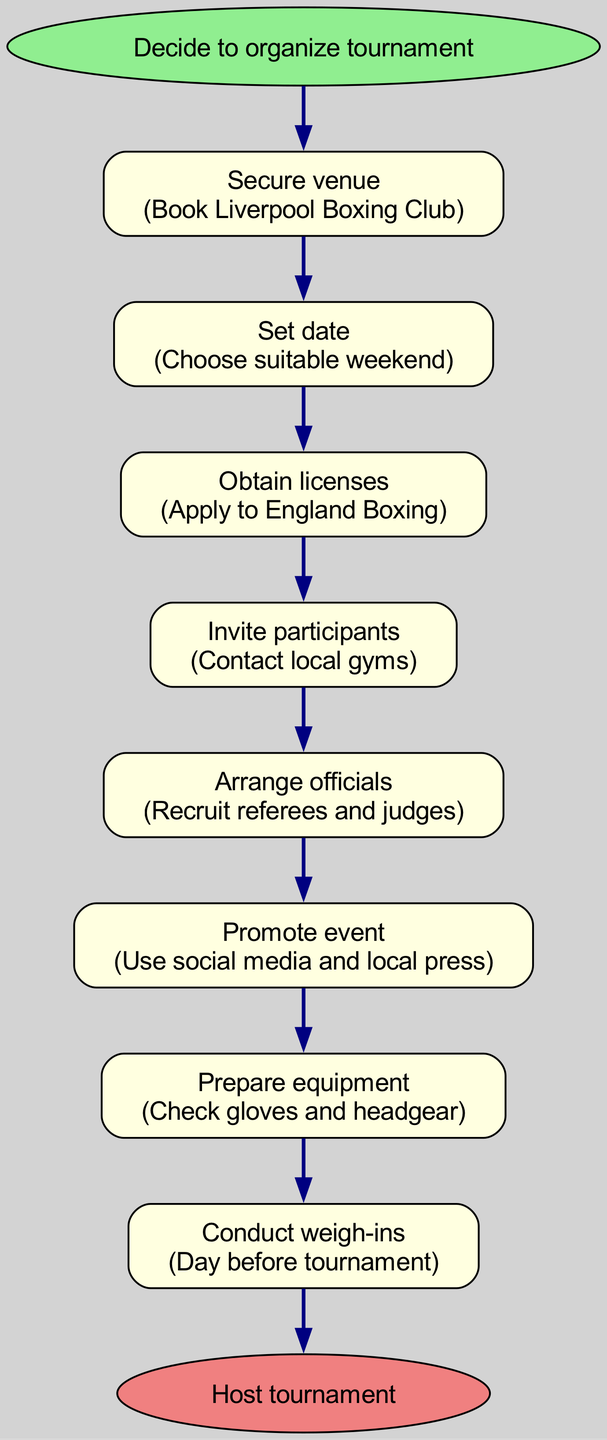What is the first step in organizing the tournament? The first step is listed directly from the start node of the diagram, which states, "Decide to organize tournament."
Answer: Decide to organize tournament How many steps are there in the process? To find the total number of steps, count each individual step node listed, which sums up to eight steps, including securing a venue, setting the date, obtaining licenses, inviting participants, arranging officials, promoting the event, preparing equipment, and conducting weigh-ins.
Answer: Eight steps What is the final outcome of this flow chart? The final outcome is indicated at the end node of the diagram, which states, "Host tournament."
Answer: Host tournament What follows after "Obtain licenses"? The diagram shows that after "Obtain licenses," the next step is "Invite participants." This is indicated by the connecting edge between the two nodes.
Answer: Invite participants What action is taken to promote the event? The relevant step in the diagram specifies that to promote the event, one should "Use social media and local press." This is detailed in the promote event node.
Answer: Use social media and local press Which step is directly before conducting weigh-ins? Referring back to the diagram flow, the step that comes directly before "Conduct weigh-ins" is "Prepare equipment." The connection between these two nodes indicates the sequence.
Answer: Prepare equipment What action is taken at the venue? The step involving the venue is "Secure venue," where the venue is booked at "Liverpool Boxing Club," which indicates the action to be performed.
Answer: Book Liverpool Boxing Club How are officials arranged for the tournament? According to the diagram, officials are arranged by "Recruiting referees and judges," detailing how officials are selected and arranged.
Answer: Recruit referees and judges 